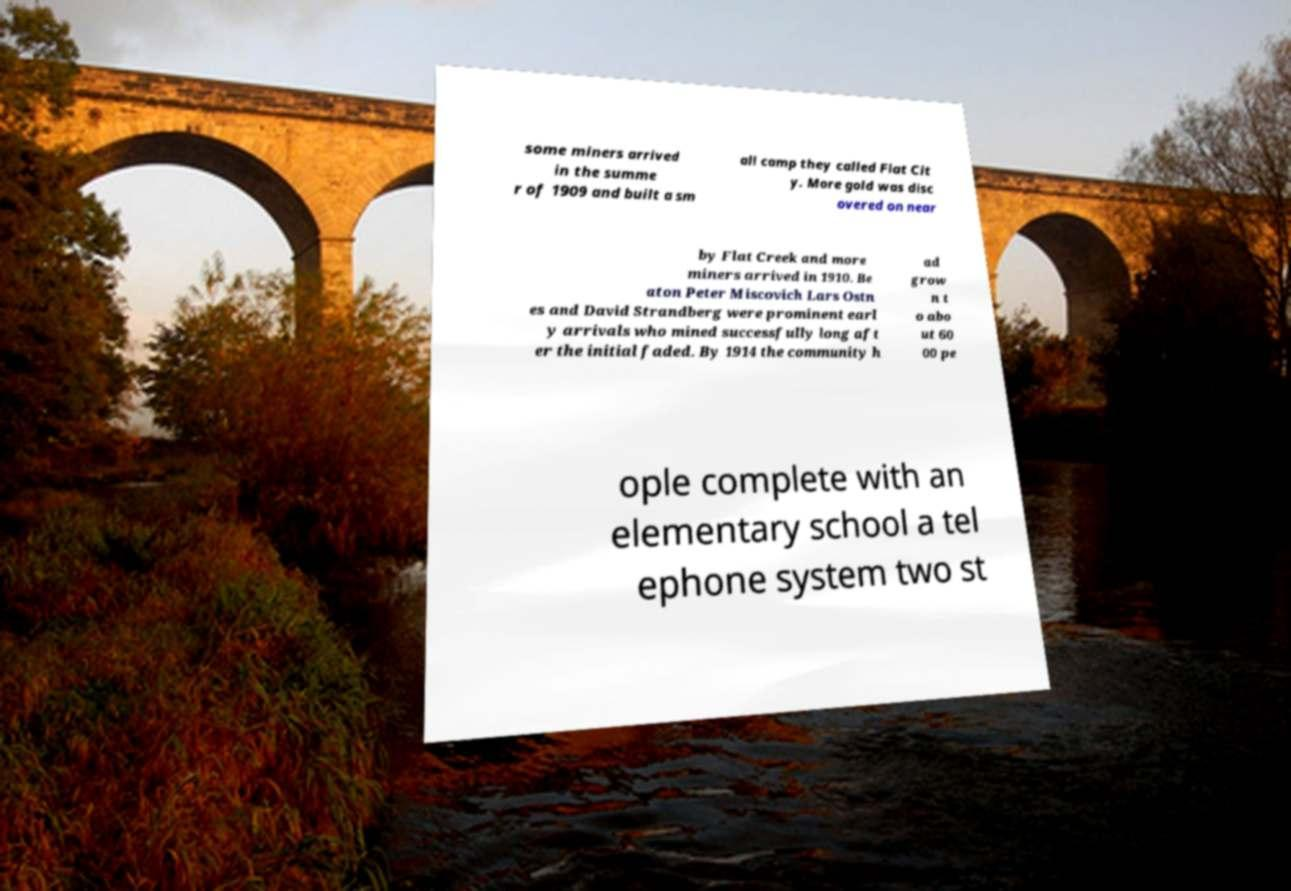Can you accurately transcribe the text from the provided image for me? some miners arrived in the summe r of 1909 and built a sm all camp they called Flat Cit y. More gold was disc overed on near by Flat Creek and more miners arrived in 1910. Be aton Peter Miscovich Lars Ostn es and David Strandberg were prominent earl y arrivals who mined successfully long aft er the initial faded. By 1914 the community h ad grow n t o abo ut 60 00 pe ople complete with an elementary school a tel ephone system two st 